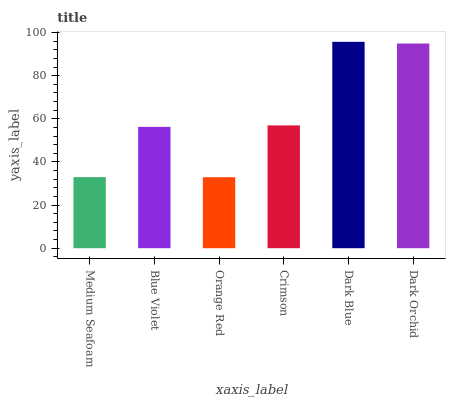Is Orange Red the minimum?
Answer yes or no. Yes. Is Dark Blue the maximum?
Answer yes or no. Yes. Is Blue Violet the minimum?
Answer yes or no. No. Is Blue Violet the maximum?
Answer yes or no. No. Is Blue Violet greater than Medium Seafoam?
Answer yes or no. Yes. Is Medium Seafoam less than Blue Violet?
Answer yes or no. Yes. Is Medium Seafoam greater than Blue Violet?
Answer yes or no. No. Is Blue Violet less than Medium Seafoam?
Answer yes or no. No. Is Crimson the high median?
Answer yes or no. Yes. Is Blue Violet the low median?
Answer yes or no. Yes. Is Blue Violet the high median?
Answer yes or no. No. Is Medium Seafoam the low median?
Answer yes or no. No. 